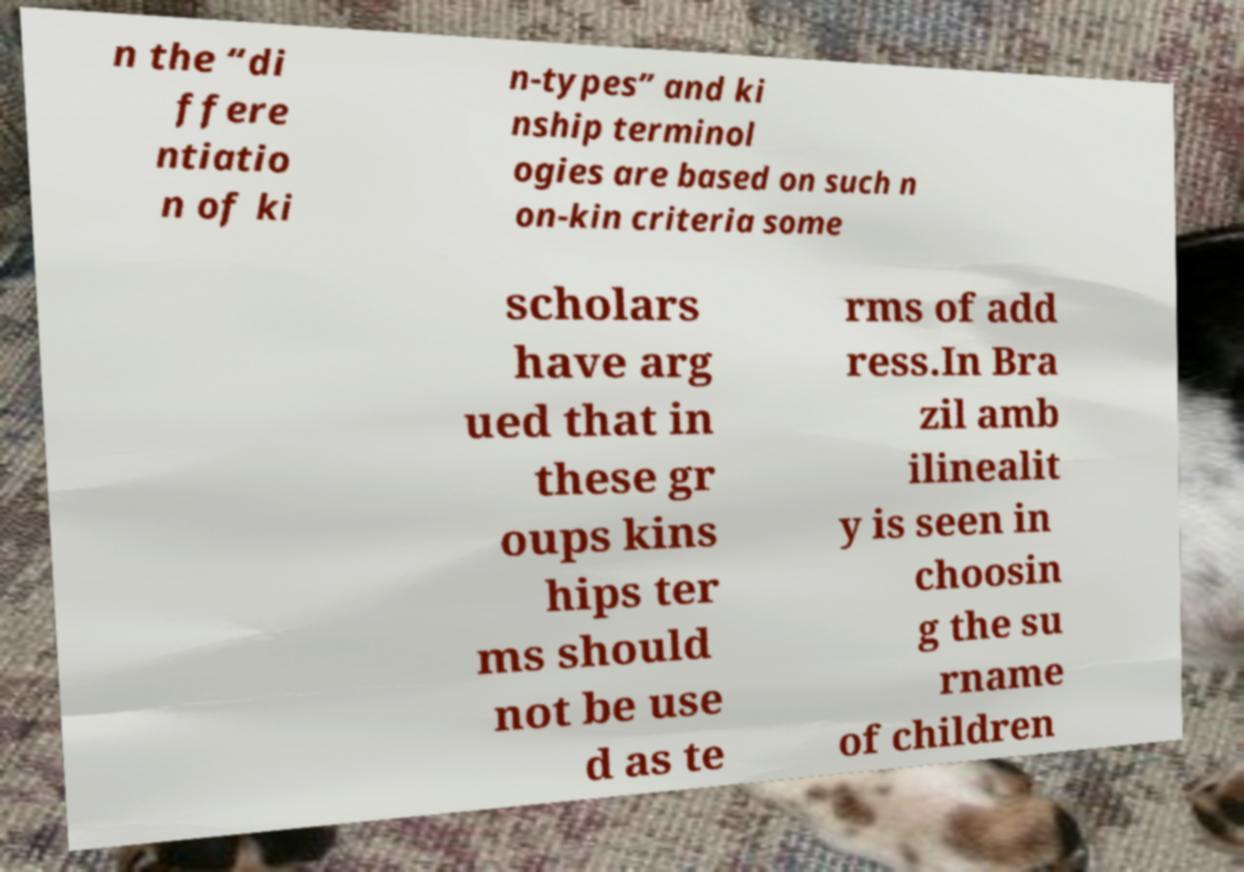Please read and relay the text visible in this image. What does it say? n the “di ffere ntiatio n of ki n-types” and ki nship terminol ogies are based on such n on-kin criteria some scholars have arg ued that in these gr oups kins hips ter ms should not be use d as te rms of add ress.In Bra zil amb ilinealit y is seen in choosin g the su rname of children 